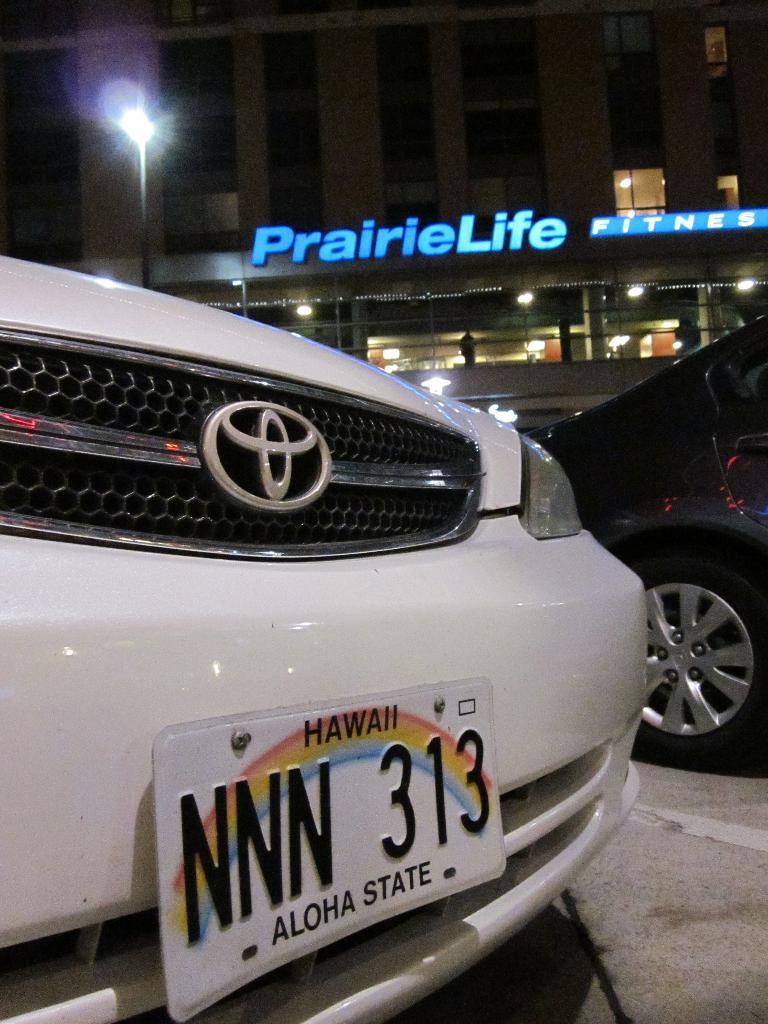Can you describe this image briefly? At the bottom of this image, there is a number plate attached to a white color vehicle. On the right side, there is a vehicle on the road. In the background, there are hoardings attached to the wall of a building, which is having glass windows and lights and there are lights arranged. And the background is dark in color. 